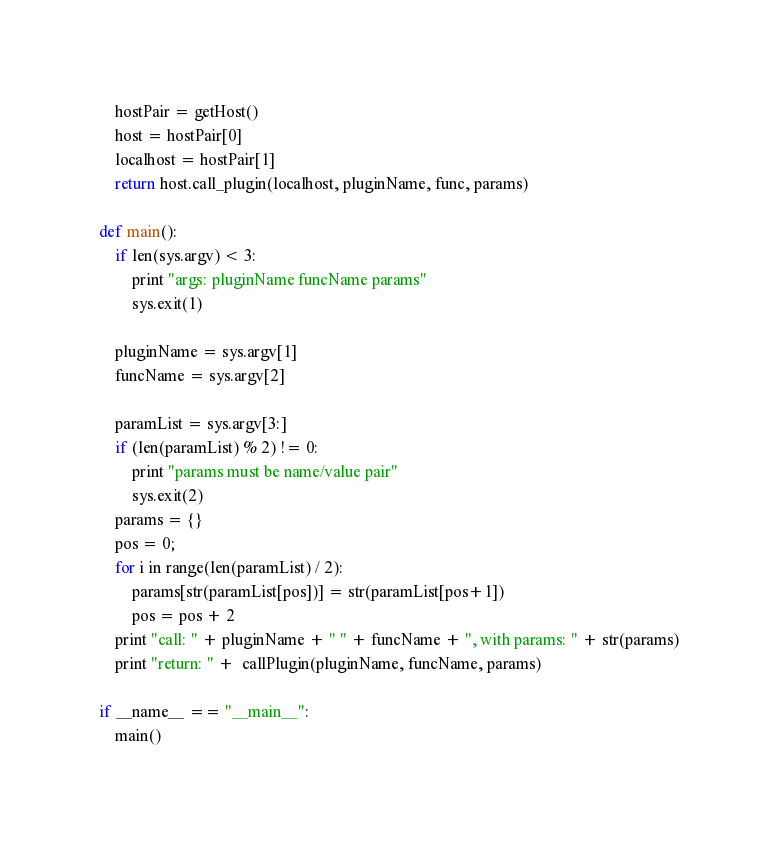Convert code to text. <code><loc_0><loc_0><loc_500><loc_500><_Python_>    hostPair = getHost()
    host = hostPair[0]
    localhost = hostPair[1]
    return host.call_plugin(localhost, pluginName, func, params)

def main():
    if len(sys.argv) < 3:
        print "args: pluginName funcName params"
        sys.exit(1)

    pluginName = sys.argv[1]
    funcName = sys.argv[2]

    paramList = sys.argv[3:]
    if (len(paramList) % 2) != 0:
        print "params must be name/value pair"
        sys.exit(2)
    params = {}
    pos = 0;
    for i in range(len(paramList) / 2):
        params[str(paramList[pos])] = str(paramList[pos+1])
        pos = pos + 2
    print "call: " + pluginName + " " + funcName + ", with params: " + str(params)
    print "return: " +  callPlugin(pluginName, funcName, params)

if __name__ == "__main__":
    main()
</code> 